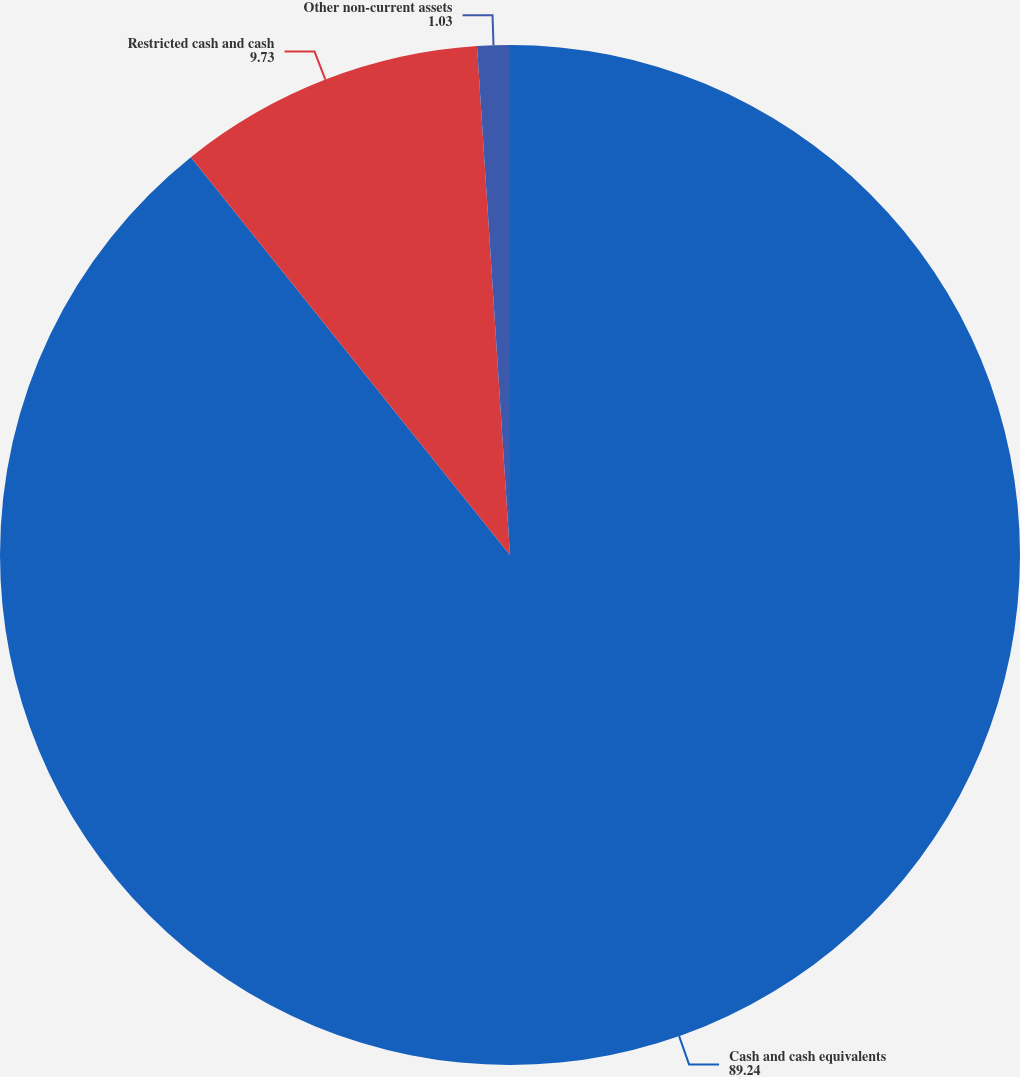Convert chart to OTSL. <chart><loc_0><loc_0><loc_500><loc_500><pie_chart><fcel>Cash and cash equivalents<fcel>Restricted cash and cash<fcel>Other non-current assets<nl><fcel>89.24%<fcel>9.73%<fcel>1.03%<nl></chart> 